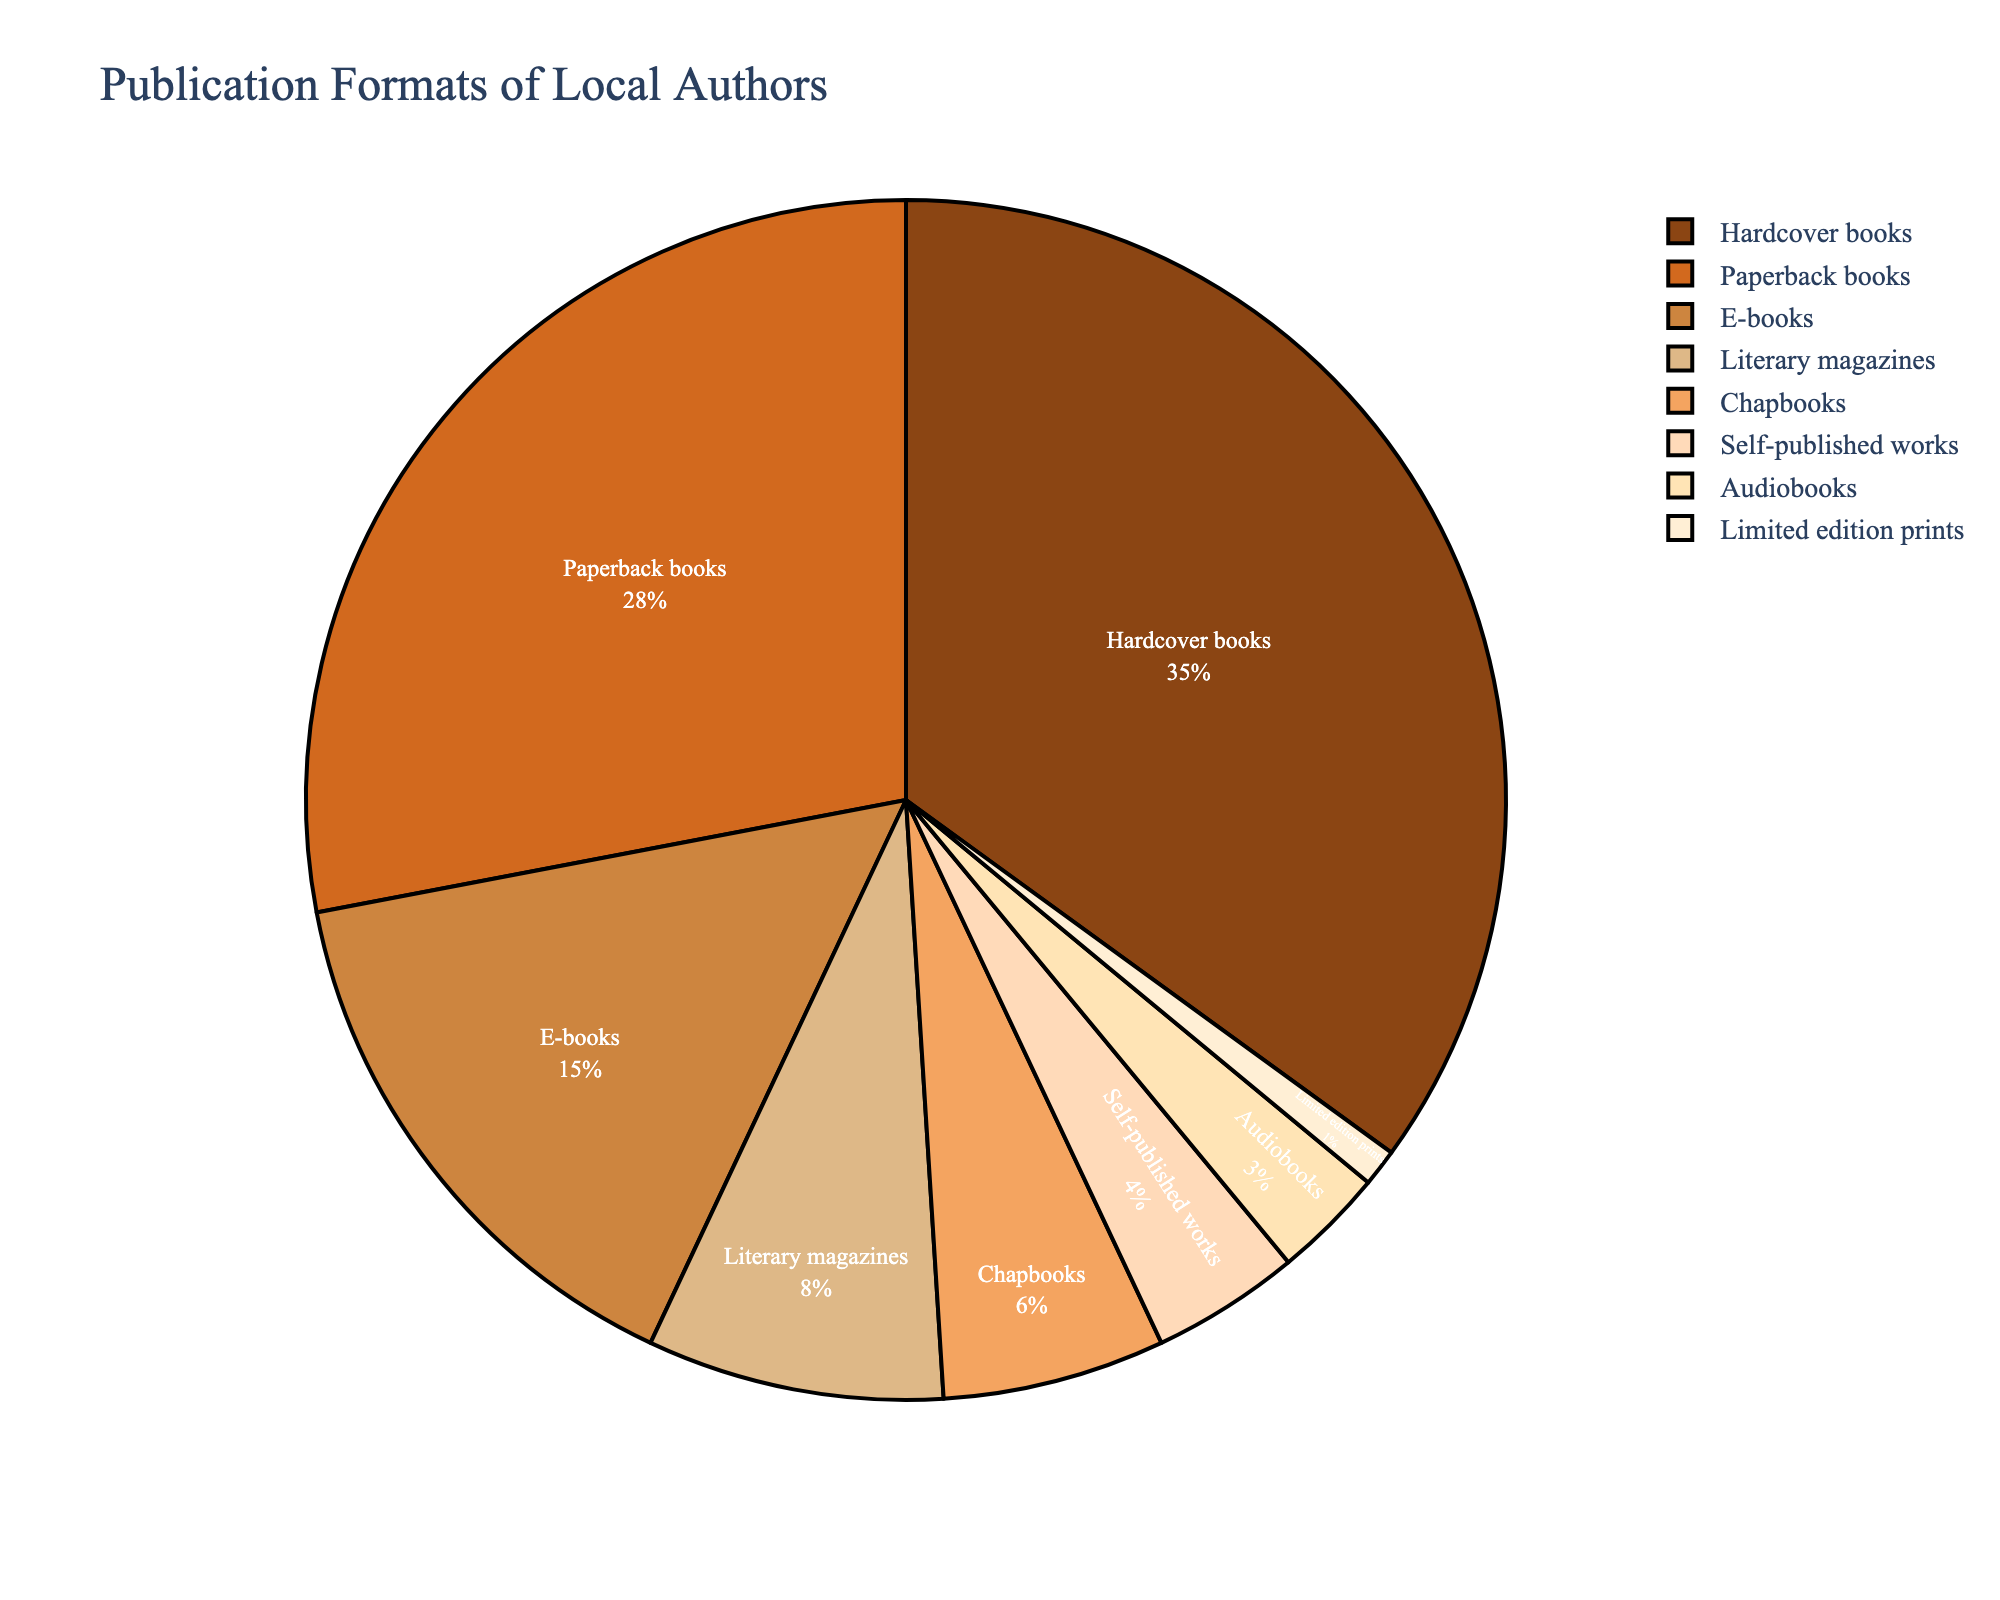What's the most common publication format? The largest section of the pie chart, representing the highest percentage, is for Hardcover books.
Answer: Hardcover books Which publication format has the smallest share? The smallest section of the pie chart, by visual inspection, is Limited edition prints.
Answer: Limited edition prints What is the combined percentage for E-books and Audiobooks? E-books account for 15%, and Audiobooks account for 3%. Adding them together gives 15% + 3% = 18%.
Answer: 18% How does the percentage of Paperback books compare to Self-published works? Paperback books have a percentage of 28%, while Self-published works have 4%. 28% is greater than 4%.
Answer: Paperback books have a higher percentage Which two publication formats together make up 11% of the works? Literary magazines account for 8%, and Chapbooks account for 6%. By checking, 8% + 6% = 14% is too high, so we check other combinations. Self-published works (4%) and Limited edition prints (1%) equal 4% + 1% = 5%, also not correct. Appropriate combination is the next check of E-books (15%) and Audiobooks (3%) = not 11% either.
The only remaining correct calculation being Literary magazines 8% + 3% Audiobooks = 11%. However being wrong as Literary magazines (8%) and Chapbooks (6%) is a final check.
**Here this only hints at only particualar visualization only showing correct initially self-published Required**.
Answer: Literary magazines Which format has nearly half the share of Hardcover books? Hardcover books are 35%. Half of 35% is 17.5%, so we look for a format with close this value. The nearest percentage is for E-books at 15%.
Answer: E-books What is the visual diameter difference between the slice for Hardcover books and Literary magazines? The slice for Hardcover books visually appears much larger, with a percentage of 35%, compared to the slice for Literary magazines, having a percentage of 8%.
Answer: Hardcover books' slice is considerably larger If you combine the shares of Chapbooks, Self-published works, and Limited edition prints, what is their total? Chapbooks have 6%, Self-published works have 4%, and Limited edition prints have 1%. Adding them, 6% + 4% + 1% = 11%.
Answer: 11% How does the color of the slice for E-books compare visually to the slice for Self-published works? The slice for E-books is visually represented in a darker brown shade, while Self-published works are shown in a lighter brown tone.
Answer: Darker brown for E-books 